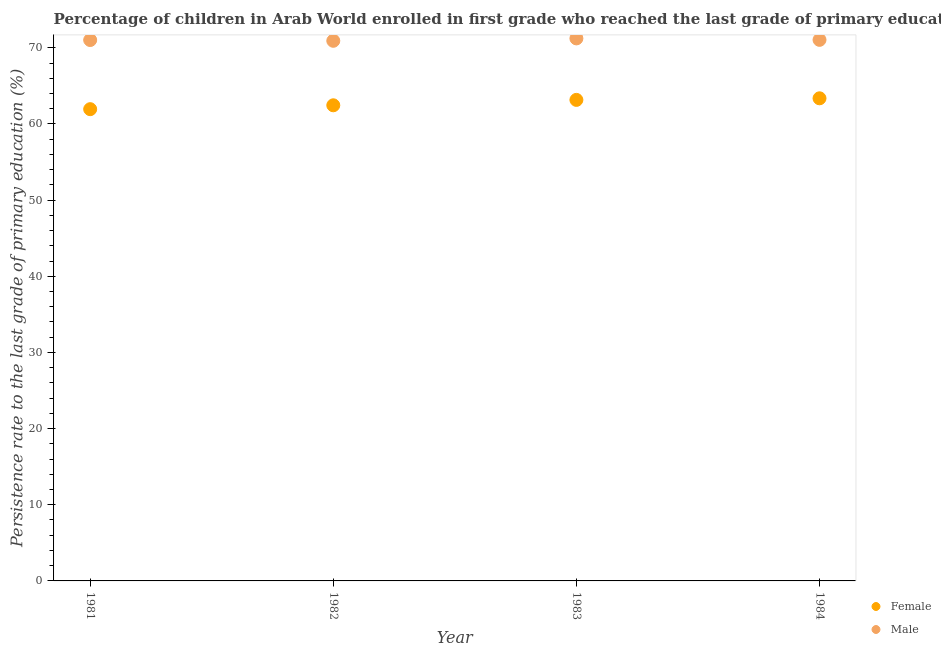What is the persistence rate of female students in 1983?
Offer a very short reply. 63.16. Across all years, what is the maximum persistence rate of male students?
Keep it short and to the point. 71.23. Across all years, what is the minimum persistence rate of male students?
Keep it short and to the point. 70.92. In which year was the persistence rate of male students minimum?
Ensure brevity in your answer.  1982. What is the total persistence rate of female students in the graph?
Give a very brief answer. 250.91. What is the difference between the persistence rate of male students in 1982 and that in 1983?
Provide a short and direct response. -0.31. What is the difference between the persistence rate of male students in 1981 and the persistence rate of female students in 1983?
Offer a terse response. 7.86. What is the average persistence rate of male students per year?
Keep it short and to the point. 71.05. In the year 1984, what is the difference between the persistence rate of female students and persistence rate of male students?
Offer a terse response. -7.67. In how many years, is the persistence rate of male students greater than 34 %?
Offer a very short reply. 4. What is the ratio of the persistence rate of female students in 1981 to that in 1984?
Offer a very short reply. 0.98. Is the difference between the persistence rate of female students in 1981 and 1984 greater than the difference between the persistence rate of male students in 1981 and 1984?
Your answer should be compact. No. What is the difference between the highest and the second highest persistence rate of female students?
Offer a very short reply. 0.21. What is the difference between the highest and the lowest persistence rate of male students?
Give a very brief answer. 0.31. Is the sum of the persistence rate of male students in 1981 and 1984 greater than the maximum persistence rate of female students across all years?
Your answer should be very brief. Yes. Does the persistence rate of male students monotonically increase over the years?
Make the answer very short. No. How many dotlines are there?
Your response must be concise. 2. Are the values on the major ticks of Y-axis written in scientific E-notation?
Your answer should be compact. No. Does the graph contain grids?
Offer a very short reply. No. How many legend labels are there?
Offer a terse response. 2. How are the legend labels stacked?
Your answer should be very brief. Vertical. What is the title of the graph?
Keep it short and to the point. Percentage of children in Arab World enrolled in first grade who reached the last grade of primary education. What is the label or title of the Y-axis?
Provide a succinct answer. Persistence rate to the last grade of primary education (%). What is the Persistence rate to the last grade of primary education (%) in Female in 1981?
Your response must be concise. 61.94. What is the Persistence rate to the last grade of primary education (%) of Male in 1981?
Offer a terse response. 71.02. What is the Persistence rate to the last grade of primary education (%) in Female in 1982?
Provide a short and direct response. 62.45. What is the Persistence rate to the last grade of primary education (%) in Male in 1982?
Your answer should be very brief. 70.92. What is the Persistence rate to the last grade of primary education (%) in Female in 1983?
Provide a short and direct response. 63.16. What is the Persistence rate to the last grade of primary education (%) in Male in 1983?
Provide a short and direct response. 71.23. What is the Persistence rate to the last grade of primary education (%) of Female in 1984?
Ensure brevity in your answer.  63.37. What is the Persistence rate to the last grade of primary education (%) in Male in 1984?
Your response must be concise. 71.04. Across all years, what is the maximum Persistence rate to the last grade of primary education (%) in Female?
Offer a very short reply. 63.37. Across all years, what is the maximum Persistence rate to the last grade of primary education (%) in Male?
Your response must be concise. 71.23. Across all years, what is the minimum Persistence rate to the last grade of primary education (%) in Female?
Your answer should be compact. 61.94. Across all years, what is the minimum Persistence rate to the last grade of primary education (%) of Male?
Provide a short and direct response. 70.92. What is the total Persistence rate to the last grade of primary education (%) in Female in the graph?
Offer a very short reply. 250.91. What is the total Persistence rate to the last grade of primary education (%) in Male in the graph?
Your response must be concise. 284.2. What is the difference between the Persistence rate to the last grade of primary education (%) of Female in 1981 and that in 1982?
Keep it short and to the point. -0.51. What is the difference between the Persistence rate to the last grade of primary education (%) of Male in 1981 and that in 1982?
Your answer should be compact. 0.1. What is the difference between the Persistence rate to the last grade of primary education (%) of Female in 1981 and that in 1983?
Give a very brief answer. -1.22. What is the difference between the Persistence rate to the last grade of primary education (%) of Male in 1981 and that in 1983?
Give a very brief answer. -0.21. What is the difference between the Persistence rate to the last grade of primary education (%) of Female in 1981 and that in 1984?
Your answer should be very brief. -1.43. What is the difference between the Persistence rate to the last grade of primary education (%) in Male in 1981 and that in 1984?
Your answer should be compact. -0.02. What is the difference between the Persistence rate to the last grade of primary education (%) in Female in 1982 and that in 1983?
Make the answer very short. -0.71. What is the difference between the Persistence rate to the last grade of primary education (%) of Male in 1982 and that in 1983?
Provide a succinct answer. -0.31. What is the difference between the Persistence rate to the last grade of primary education (%) in Female in 1982 and that in 1984?
Your answer should be very brief. -0.92. What is the difference between the Persistence rate to the last grade of primary education (%) of Male in 1982 and that in 1984?
Provide a succinct answer. -0.12. What is the difference between the Persistence rate to the last grade of primary education (%) in Female in 1983 and that in 1984?
Ensure brevity in your answer.  -0.21. What is the difference between the Persistence rate to the last grade of primary education (%) in Male in 1983 and that in 1984?
Offer a terse response. 0.19. What is the difference between the Persistence rate to the last grade of primary education (%) in Female in 1981 and the Persistence rate to the last grade of primary education (%) in Male in 1982?
Keep it short and to the point. -8.98. What is the difference between the Persistence rate to the last grade of primary education (%) of Female in 1981 and the Persistence rate to the last grade of primary education (%) of Male in 1983?
Offer a very short reply. -9.29. What is the difference between the Persistence rate to the last grade of primary education (%) of Female in 1981 and the Persistence rate to the last grade of primary education (%) of Male in 1984?
Keep it short and to the point. -9.1. What is the difference between the Persistence rate to the last grade of primary education (%) in Female in 1982 and the Persistence rate to the last grade of primary education (%) in Male in 1983?
Offer a very short reply. -8.78. What is the difference between the Persistence rate to the last grade of primary education (%) in Female in 1982 and the Persistence rate to the last grade of primary education (%) in Male in 1984?
Your answer should be very brief. -8.59. What is the difference between the Persistence rate to the last grade of primary education (%) in Female in 1983 and the Persistence rate to the last grade of primary education (%) in Male in 1984?
Give a very brief answer. -7.88. What is the average Persistence rate to the last grade of primary education (%) of Female per year?
Give a very brief answer. 62.73. What is the average Persistence rate to the last grade of primary education (%) in Male per year?
Give a very brief answer. 71.05. In the year 1981, what is the difference between the Persistence rate to the last grade of primary education (%) of Female and Persistence rate to the last grade of primary education (%) of Male?
Ensure brevity in your answer.  -9.08. In the year 1982, what is the difference between the Persistence rate to the last grade of primary education (%) in Female and Persistence rate to the last grade of primary education (%) in Male?
Give a very brief answer. -8.47. In the year 1983, what is the difference between the Persistence rate to the last grade of primary education (%) of Female and Persistence rate to the last grade of primary education (%) of Male?
Your answer should be compact. -8.07. In the year 1984, what is the difference between the Persistence rate to the last grade of primary education (%) of Female and Persistence rate to the last grade of primary education (%) of Male?
Your answer should be very brief. -7.67. What is the ratio of the Persistence rate to the last grade of primary education (%) in Female in 1981 to that in 1982?
Provide a succinct answer. 0.99. What is the ratio of the Persistence rate to the last grade of primary education (%) in Female in 1981 to that in 1983?
Provide a short and direct response. 0.98. What is the ratio of the Persistence rate to the last grade of primary education (%) of Male in 1981 to that in 1983?
Provide a short and direct response. 1. What is the ratio of the Persistence rate to the last grade of primary education (%) in Female in 1981 to that in 1984?
Ensure brevity in your answer.  0.98. What is the ratio of the Persistence rate to the last grade of primary education (%) of Female in 1982 to that in 1984?
Provide a short and direct response. 0.99. What is the ratio of the Persistence rate to the last grade of primary education (%) in Male in 1982 to that in 1984?
Give a very brief answer. 1. What is the difference between the highest and the second highest Persistence rate to the last grade of primary education (%) in Female?
Offer a very short reply. 0.21. What is the difference between the highest and the second highest Persistence rate to the last grade of primary education (%) of Male?
Your answer should be very brief. 0.19. What is the difference between the highest and the lowest Persistence rate to the last grade of primary education (%) of Female?
Give a very brief answer. 1.43. What is the difference between the highest and the lowest Persistence rate to the last grade of primary education (%) of Male?
Keep it short and to the point. 0.31. 